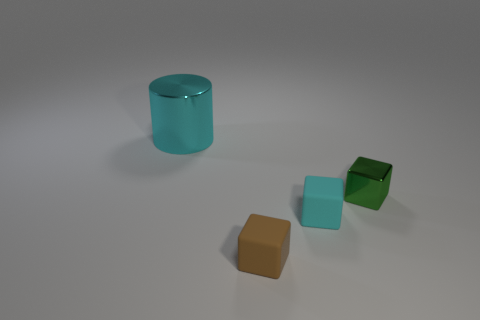Add 1 tiny brown matte cubes. How many objects exist? 5 Subtract all cylinders. How many objects are left? 3 Subtract all metallic cylinders. Subtract all green shiny objects. How many objects are left? 2 Add 1 tiny brown objects. How many tiny brown objects are left? 2 Add 4 gray cylinders. How many gray cylinders exist? 4 Subtract 0 gray cylinders. How many objects are left? 4 